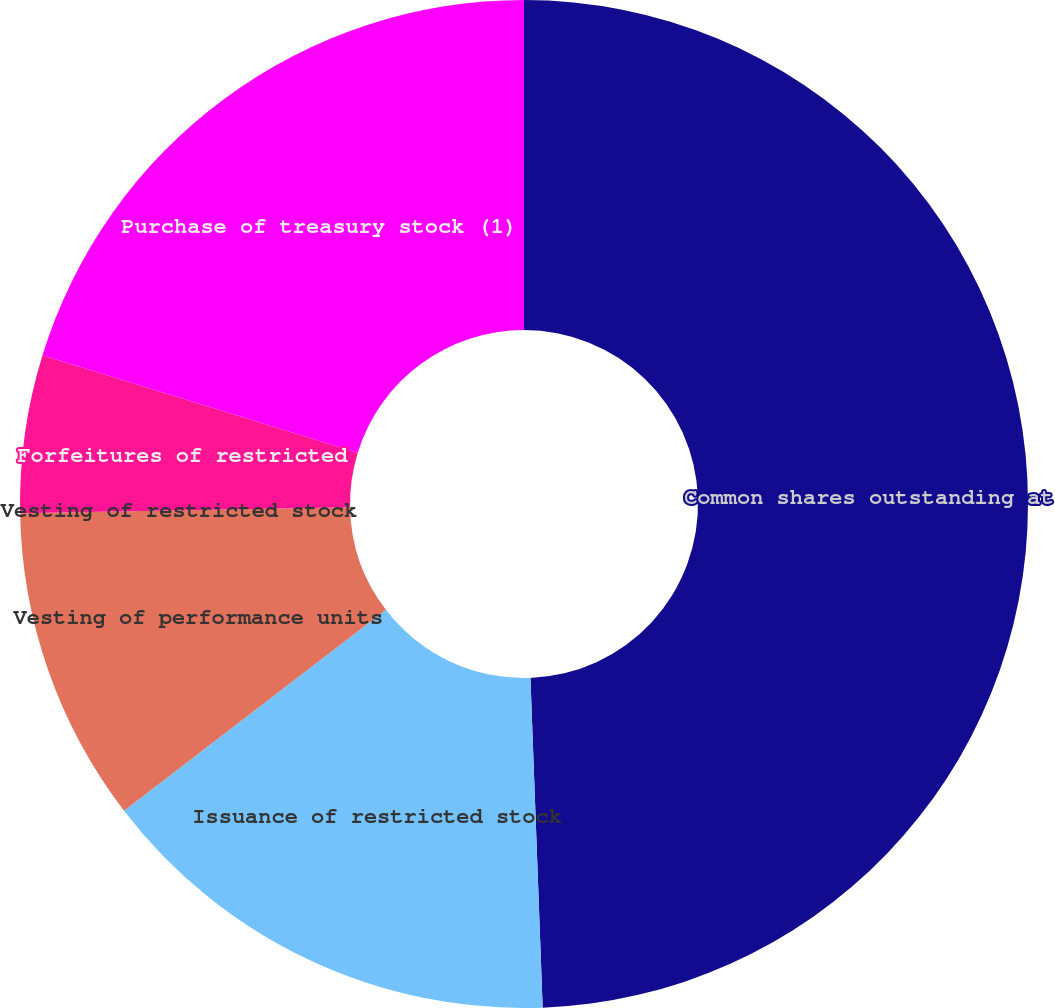Convert chart to OTSL. <chart><loc_0><loc_0><loc_500><loc_500><pie_chart><fcel>Common shares outstanding at<fcel>Issuance of restricted stock<fcel>Vesting of performance units<fcel>Vesting of restricted stock<fcel>Forfeitures of restricted<fcel>Purchase of treasury stock (1)<nl><fcel>49.41%<fcel>15.18%<fcel>10.12%<fcel>0.0%<fcel>5.06%<fcel>20.23%<nl></chart> 